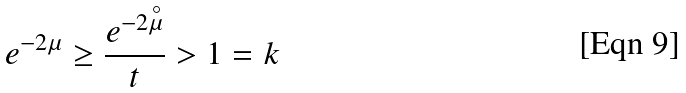<formula> <loc_0><loc_0><loc_500><loc_500>e ^ { - 2 \mu } \geq \frac { e ^ { - 2 \overset { \circ } { \mu } } } { t } > 1 = k</formula> 